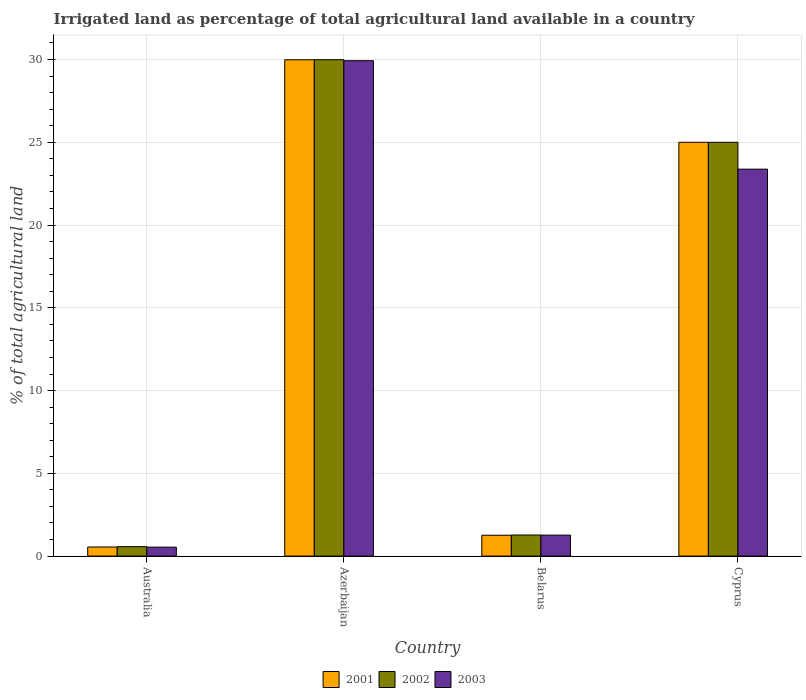How many different coloured bars are there?
Keep it short and to the point. 3. Are the number of bars per tick equal to the number of legend labels?
Offer a terse response. Yes. How many bars are there on the 2nd tick from the left?
Give a very brief answer. 3. How many bars are there on the 3rd tick from the right?
Your answer should be very brief. 3. What is the label of the 4th group of bars from the left?
Provide a succinct answer. Cyprus. What is the percentage of irrigated land in 2003 in Cyprus?
Provide a succinct answer. 23.38. Across all countries, what is the maximum percentage of irrigated land in 2003?
Keep it short and to the point. 29.93. Across all countries, what is the minimum percentage of irrigated land in 2002?
Your answer should be compact. 0.57. In which country was the percentage of irrigated land in 2001 maximum?
Give a very brief answer. Azerbaijan. In which country was the percentage of irrigated land in 2002 minimum?
Give a very brief answer. Australia. What is the total percentage of irrigated land in 2001 in the graph?
Ensure brevity in your answer.  56.8. What is the difference between the percentage of irrigated land in 2003 in Australia and that in Azerbaijan?
Keep it short and to the point. -29.39. What is the difference between the percentage of irrigated land in 2003 in Cyprus and the percentage of irrigated land in 2002 in Belarus?
Your answer should be compact. 22.1. What is the average percentage of irrigated land in 2003 per country?
Ensure brevity in your answer.  13.78. What is the difference between the percentage of irrigated land of/in 2003 and percentage of irrigated land of/in 2002 in Belarus?
Provide a short and direct response. -0.01. In how many countries, is the percentage of irrigated land in 2003 greater than 12 %?
Offer a terse response. 2. What is the ratio of the percentage of irrigated land in 2001 in Australia to that in Belarus?
Make the answer very short. 0.44. Is the difference between the percentage of irrigated land in 2003 in Australia and Cyprus greater than the difference between the percentage of irrigated land in 2002 in Australia and Cyprus?
Ensure brevity in your answer.  Yes. What is the difference between the highest and the second highest percentage of irrigated land in 2003?
Your answer should be very brief. -28.66. What is the difference between the highest and the lowest percentage of irrigated land in 2003?
Provide a short and direct response. 29.39. What does the 2nd bar from the right in Cyprus represents?
Provide a succinct answer. 2002. Is it the case that in every country, the sum of the percentage of irrigated land in 2001 and percentage of irrigated land in 2003 is greater than the percentage of irrigated land in 2002?
Ensure brevity in your answer.  Yes. Are all the bars in the graph horizontal?
Offer a very short reply. No. How many countries are there in the graph?
Offer a terse response. 4. Are the values on the major ticks of Y-axis written in scientific E-notation?
Give a very brief answer. No. Does the graph contain any zero values?
Keep it short and to the point. No. What is the title of the graph?
Ensure brevity in your answer.  Irrigated land as percentage of total agricultural land available in a country. Does "2008" appear as one of the legend labels in the graph?
Your answer should be compact. No. What is the label or title of the Y-axis?
Your answer should be compact. % of total agricultural land. What is the % of total agricultural land in 2001 in Australia?
Your answer should be very brief. 0.55. What is the % of total agricultural land of 2002 in Australia?
Your answer should be very brief. 0.57. What is the % of total agricultural land in 2003 in Australia?
Your response must be concise. 0.54. What is the % of total agricultural land in 2001 in Azerbaijan?
Keep it short and to the point. 29.99. What is the % of total agricultural land of 2002 in Azerbaijan?
Offer a very short reply. 29.99. What is the % of total agricultural land in 2003 in Azerbaijan?
Provide a short and direct response. 29.93. What is the % of total agricultural land of 2001 in Belarus?
Your answer should be compact. 1.26. What is the % of total agricultural land in 2002 in Belarus?
Keep it short and to the point. 1.27. What is the % of total agricultural land of 2003 in Belarus?
Keep it short and to the point. 1.27. What is the % of total agricultural land in 2001 in Cyprus?
Your answer should be very brief. 25. What is the % of total agricultural land of 2003 in Cyprus?
Make the answer very short. 23.38. Across all countries, what is the maximum % of total agricultural land in 2001?
Offer a very short reply. 29.99. Across all countries, what is the maximum % of total agricultural land of 2002?
Keep it short and to the point. 29.99. Across all countries, what is the maximum % of total agricultural land in 2003?
Keep it short and to the point. 29.93. Across all countries, what is the minimum % of total agricultural land in 2001?
Make the answer very short. 0.55. Across all countries, what is the minimum % of total agricultural land of 2002?
Make the answer very short. 0.57. Across all countries, what is the minimum % of total agricultural land in 2003?
Ensure brevity in your answer.  0.54. What is the total % of total agricultural land of 2001 in the graph?
Keep it short and to the point. 56.8. What is the total % of total agricultural land in 2002 in the graph?
Make the answer very short. 56.83. What is the total % of total agricultural land of 2003 in the graph?
Keep it short and to the point. 55.12. What is the difference between the % of total agricultural land of 2001 in Australia and that in Azerbaijan?
Your response must be concise. -29.44. What is the difference between the % of total agricultural land in 2002 in Australia and that in Azerbaijan?
Make the answer very short. -29.42. What is the difference between the % of total agricultural land of 2003 in Australia and that in Azerbaijan?
Give a very brief answer. -29.39. What is the difference between the % of total agricultural land of 2001 in Australia and that in Belarus?
Make the answer very short. -0.71. What is the difference between the % of total agricultural land in 2002 in Australia and that in Belarus?
Ensure brevity in your answer.  -0.7. What is the difference between the % of total agricultural land in 2003 in Australia and that in Belarus?
Provide a succinct answer. -0.73. What is the difference between the % of total agricultural land of 2001 in Australia and that in Cyprus?
Your answer should be compact. -24.45. What is the difference between the % of total agricultural land in 2002 in Australia and that in Cyprus?
Ensure brevity in your answer.  -24.43. What is the difference between the % of total agricultural land in 2003 in Australia and that in Cyprus?
Offer a terse response. -22.84. What is the difference between the % of total agricultural land in 2001 in Azerbaijan and that in Belarus?
Your answer should be very brief. 28.73. What is the difference between the % of total agricultural land in 2002 in Azerbaijan and that in Belarus?
Make the answer very short. 28.72. What is the difference between the % of total agricultural land of 2003 in Azerbaijan and that in Belarus?
Provide a succinct answer. 28.66. What is the difference between the % of total agricultural land in 2001 in Azerbaijan and that in Cyprus?
Your response must be concise. 4.99. What is the difference between the % of total agricultural land in 2002 in Azerbaijan and that in Cyprus?
Offer a very short reply. 4.99. What is the difference between the % of total agricultural land in 2003 in Azerbaijan and that in Cyprus?
Offer a very short reply. 6.55. What is the difference between the % of total agricultural land in 2001 in Belarus and that in Cyprus?
Ensure brevity in your answer.  -23.74. What is the difference between the % of total agricultural land in 2002 in Belarus and that in Cyprus?
Ensure brevity in your answer.  -23.73. What is the difference between the % of total agricultural land in 2003 in Belarus and that in Cyprus?
Your answer should be very brief. -22.11. What is the difference between the % of total agricultural land in 2001 in Australia and the % of total agricultural land in 2002 in Azerbaijan?
Your response must be concise. -29.44. What is the difference between the % of total agricultural land of 2001 in Australia and the % of total agricultural land of 2003 in Azerbaijan?
Provide a short and direct response. -29.38. What is the difference between the % of total agricultural land in 2002 in Australia and the % of total agricultural land in 2003 in Azerbaijan?
Provide a succinct answer. -29.36. What is the difference between the % of total agricultural land in 2001 in Australia and the % of total agricultural land in 2002 in Belarus?
Offer a terse response. -0.72. What is the difference between the % of total agricultural land in 2001 in Australia and the % of total agricultural land in 2003 in Belarus?
Provide a succinct answer. -0.72. What is the difference between the % of total agricultural land in 2002 in Australia and the % of total agricultural land in 2003 in Belarus?
Offer a very short reply. -0.7. What is the difference between the % of total agricultural land in 2001 in Australia and the % of total agricultural land in 2002 in Cyprus?
Make the answer very short. -24.45. What is the difference between the % of total agricultural land of 2001 in Australia and the % of total agricultural land of 2003 in Cyprus?
Your answer should be compact. -22.83. What is the difference between the % of total agricultural land in 2002 in Australia and the % of total agricultural land in 2003 in Cyprus?
Ensure brevity in your answer.  -22.81. What is the difference between the % of total agricultural land of 2001 in Azerbaijan and the % of total agricultural land of 2002 in Belarus?
Your response must be concise. 28.71. What is the difference between the % of total agricultural land of 2001 in Azerbaijan and the % of total agricultural land of 2003 in Belarus?
Your answer should be very brief. 28.72. What is the difference between the % of total agricultural land of 2002 in Azerbaijan and the % of total agricultural land of 2003 in Belarus?
Provide a succinct answer. 28.72. What is the difference between the % of total agricultural land of 2001 in Azerbaijan and the % of total agricultural land of 2002 in Cyprus?
Give a very brief answer. 4.99. What is the difference between the % of total agricultural land in 2001 in Azerbaijan and the % of total agricultural land in 2003 in Cyprus?
Your answer should be very brief. 6.61. What is the difference between the % of total agricultural land of 2002 in Azerbaijan and the % of total agricultural land of 2003 in Cyprus?
Your answer should be compact. 6.61. What is the difference between the % of total agricultural land in 2001 in Belarus and the % of total agricultural land in 2002 in Cyprus?
Make the answer very short. -23.74. What is the difference between the % of total agricultural land in 2001 in Belarus and the % of total agricultural land in 2003 in Cyprus?
Your answer should be compact. -22.12. What is the difference between the % of total agricultural land in 2002 in Belarus and the % of total agricultural land in 2003 in Cyprus?
Your answer should be very brief. -22.1. What is the average % of total agricultural land of 2001 per country?
Provide a short and direct response. 14.2. What is the average % of total agricultural land of 2002 per country?
Provide a succinct answer. 14.21. What is the average % of total agricultural land in 2003 per country?
Provide a succinct answer. 13.78. What is the difference between the % of total agricultural land in 2001 and % of total agricultural land in 2002 in Australia?
Provide a succinct answer. -0.02. What is the difference between the % of total agricultural land of 2001 and % of total agricultural land of 2003 in Australia?
Offer a very short reply. 0.01. What is the difference between the % of total agricultural land of 2002 and % of total agricultural land of 2003 in Australia?
Make the answer very short. 0.03. What is the difference between the % of total agricultural land in 2001 and % of total agricultural land in 2002 in Azerbaijan?
Keep it short and to the point. -0. What is the difference between the % of total agricultural land in 2001 and % of total agricultural land in 2003 in Azerbaijan?
Your answer should be very brief. 0.06. What is the difference between the % of total agricultural land in 2002 and % of total agricultural land in 2003 in Azerbaijan?
Provide a short and direct response. 0.06. What is the difference between the % of total agricultural land in 2001 and % of total agricultural land in 2002 in Belarus?
Ensure brevity in your answer.  -0.01. What is the difference between the % of total agricultural land in 2001 and % of total agricultural land in 2003 in Belarus?
Give a very brief answer. -0.01. What is the difference between the % of total agricultural land of 2002 and % of total agricultural land of 2003 in Belarus?
Your answer should be compact. 0.01. What is the difference between the % of total agricultural land in 2001 and % of total agricultural land in 2002 in Cyprus?
Ensure brevity in your answer.  0. What is the difference between the % of total agricultural land of 2001 and % of total agricultural land of 2003 in Cyprus?
Provide a short and direct response. 1.62. What is the difference between the % of total agricultural land in 2002 and % of total agricultural land in 2003 in Cyprus?
Your response must be concise. 1.62. What is the ratio of the % of total agricultural land in 2001 in Australia to that in Azerbaijan?
Your answer should be compact. 0.02. What is the ratio of the % of total agricultural land in 2002 in Australia to that in Azerbaijan?
Your response must be concise. 0.02. What is the ratio of the % of total agricultural land in 2003 in Australia to that in Azerbaijan?
Your response must be concise. 0.02. What is the ratio of the % of total agricultural land of 2001 in Australia to that in Belarus?
Ensure brevity in your answer.  0.44. What is the ratio of the % of total agricultural land of 2002 in Australia to that in Belarus?
Provide a succinct answer. 0.45. What is the ratio of the % of total agricultural land in 2003 in Australia to that in Belarus?
Ensure brevity in your answer.  0.43. What is the ratio of the % of total agricultural land of 2001 in Australia to that in Cyprus?
Keep it short and to the point. 0.02. What is the ratio of the % of total agricultural land in 2002 in Australia to that in Cyprus?
Your response must be concise. 0.02. What is the ratio of the % of total agricultural land of 2003 in Australia to that in Cyprus?
Your answer should be very brief. 0.02. What is the ratio of the % of total agricultural land in 2001 in Azerbaijan to that in Belarus?
Your answer should be very brief. 23.8. What is the ratio of the % of total agricultural land in 2002 in Azerbaijan to that in Belarus?
Ensure brevity in your answer.  23.54. What is the ratio of the % of total agricultural land in 2003 in Azerbaijan to that in Belarus?
Your answer should be very brief. 23.59. What is the ratio of the % of total agricultural land of 2001 in Azerbaijan to that in Cyprus?
Give a very brief answer. 1.2. What is the ratio of the % of total agricultural land in 2002 in Azerbaijan to that in Cyprus?
Provide a succinct answer. 1.2. What is the ratio of the % of total agricultural land of 2003 in Azerbaijan to that in Cyprus?
Ensure brevity in your answer.  1.28. What is the ratio of the % of total agricultural land in 2001 in Belarus to that in Cyprus?
Keep it short and to the point. 0.05. What is the ratio of the % of total agricultural land of 2002 in Belarus to that in Cyprus?
Ensure brevity in your answer.  0.05. What is the ratio of the % of total agricultural land in 2003 in Belarus to that in Cyprus?
Provide a succinct answer. 0.05. What is the difference between the highest and the second highest % of total agricultural land of 2001?
Your answer should be compact. 4.99. What is the difference between the highest and the second highest % of total agricultural land in 2002?
Your answer should be compact. 4.99. What is the difference between the highest and the second highest % of total agricultural land of 2003?
Offer a very short reply. 6.55. What is the difference between the highest and the lowest % of total agricultural land of 2001?
Offer a very short reply. 29.44. What is the difference between the highest and the lowest % of total agricultural land of 2002?
Your response must be concise. 29.42. What is the difference between the highest and the lowest % of total agricultural land of 2003?
Ensure brevity in your answer.  29.39. 